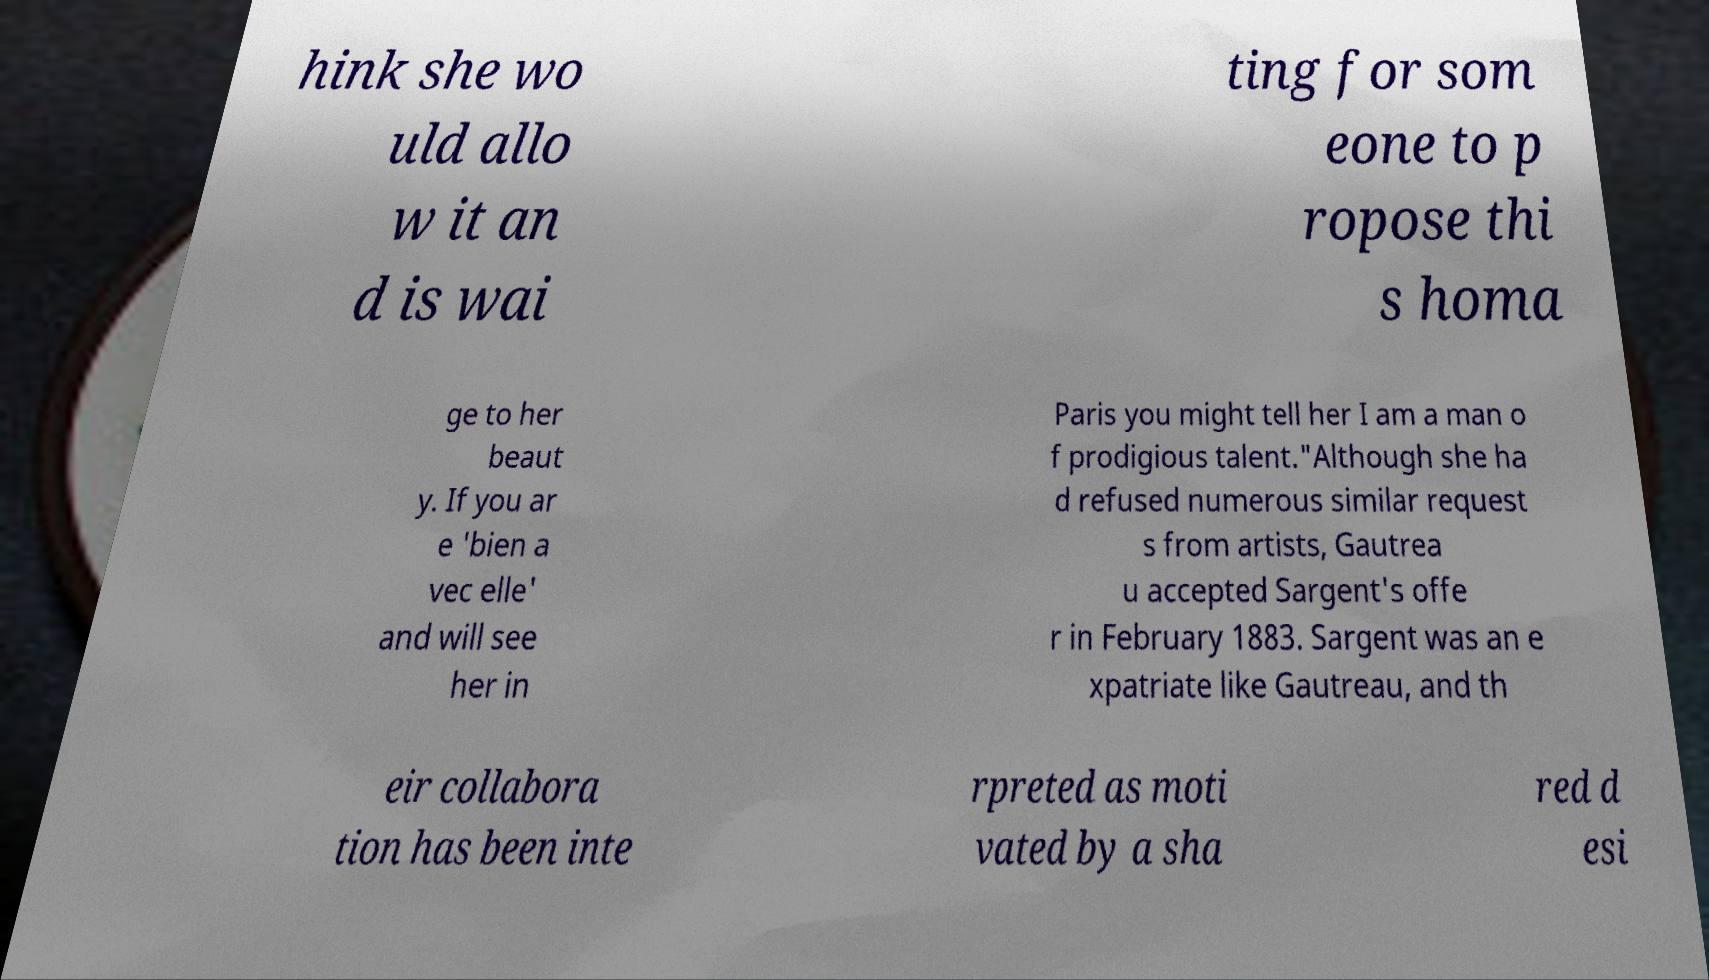Can you read and provide the text displayed in the image?This photo seems to have some interesting text. Can you extract and type it out for me? hink she wo uld allo w it an d is wai ting for som eone to p ropose thi s homa ge to her beaut y. If you ar e 'bien a vec elle' and will see her in Paris you might tell her I am a man o f prodigious talent."Although she ha d refused numerous similar request s from artists, Gautrea u accepted Sargent's offe r in February 1883. Sargent was an e xpatriate like Gautreau, and th eir collabora tion has been inte rpreted as moti vated by a sha red d esi 